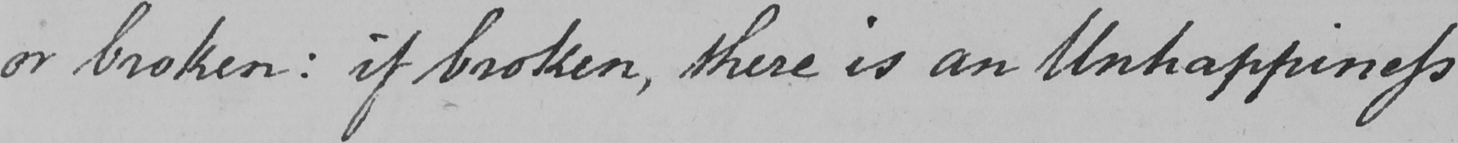Can you tell me what this handwritten text says? or broken :  if broken , there is an Unhappiness 